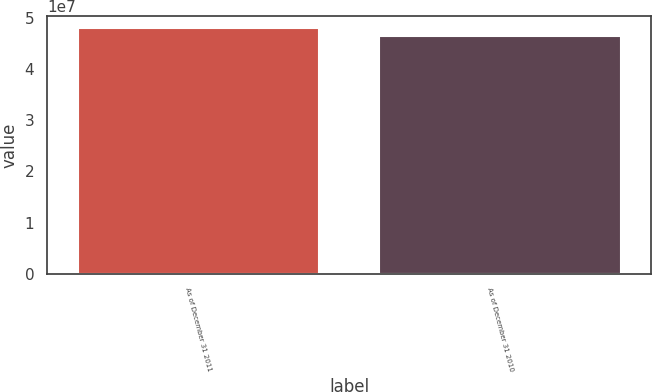Convert chart to OTSL. <chart><loc_0><loc_0><loc_500><loc_500><bar_chart><fcel>As of December 31 2011<fcel>As of December 31 2010<nl><fcel>4.79405e+07<fcel>4.6373e+07<nl></chart> 